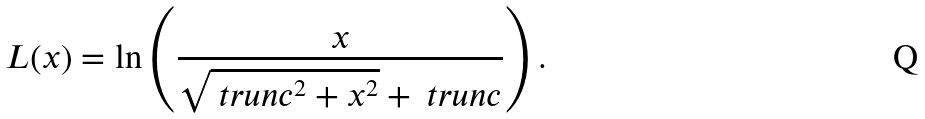Convert formula to latex. <formula><loc_0><loc_0><loc_500><loc_500>L ( x ) = \ln \left ( \frac { x } { \sqrt { \ t r u n c ^ { 2 } + x ^ { 2 } } + \ t r u n c } \right ) .</formula> 